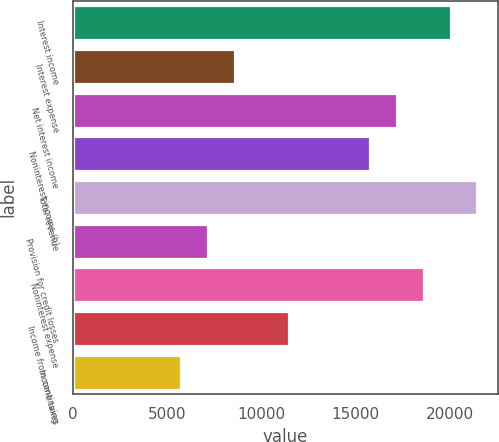Convert chart to OTSL. <chart><loc_0><loc_0><loc_500><loc_500><bar_chart><fcel>Interest income<fcel>Interest expense<fcel>Net interest income<fcel>Noninterest income (b)<fcel>Total revenue<fcel>Provision for credit losses<fcel>Noninterest expense<fcel>Income from continuing<fcel>Income taxes<nl><fcel>20056<fcel>8596.07<fcel>17191<fcel>15758.5<fcel>21488.5<fcel>7163.58<fcel>18623.5<fcel>11461<fcel>5731.09<nl></chart> 